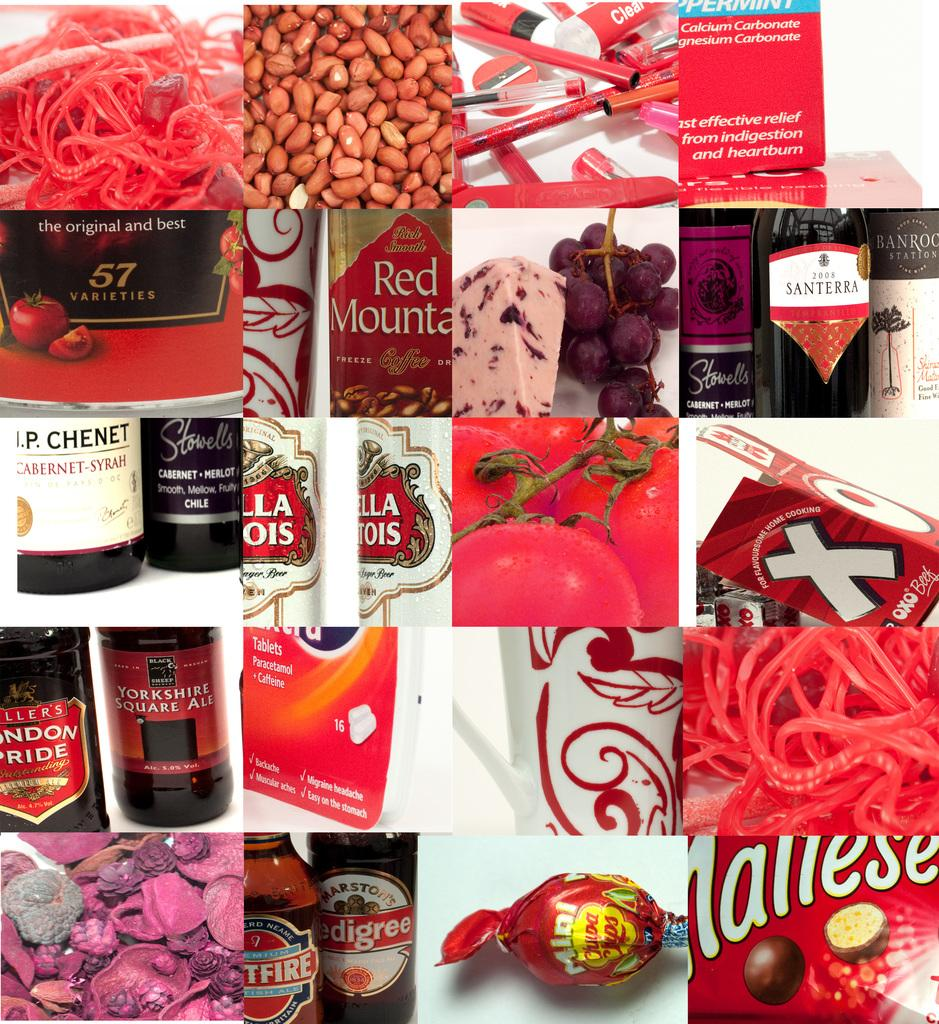<image>
Summarize the visual content of the image. montage of squares featuring products such as red mountain coffee, yorkshire square ale, chupa pops, and santerra 